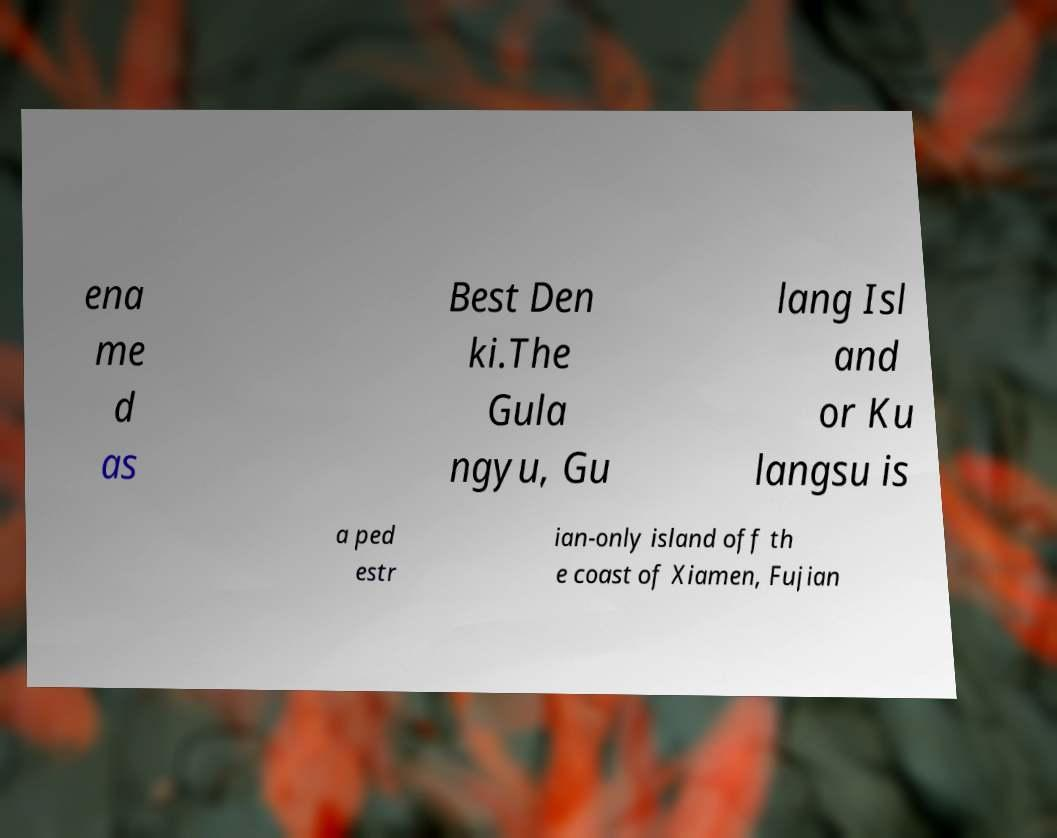Please read and relay the text visible in this image. What does it say? ena me d as Best Den ki.The Gula ngyu, Gu lang Isl and or Ku langsu is a ped estr ian-only island off th e coast of Xiamen, Fujian 